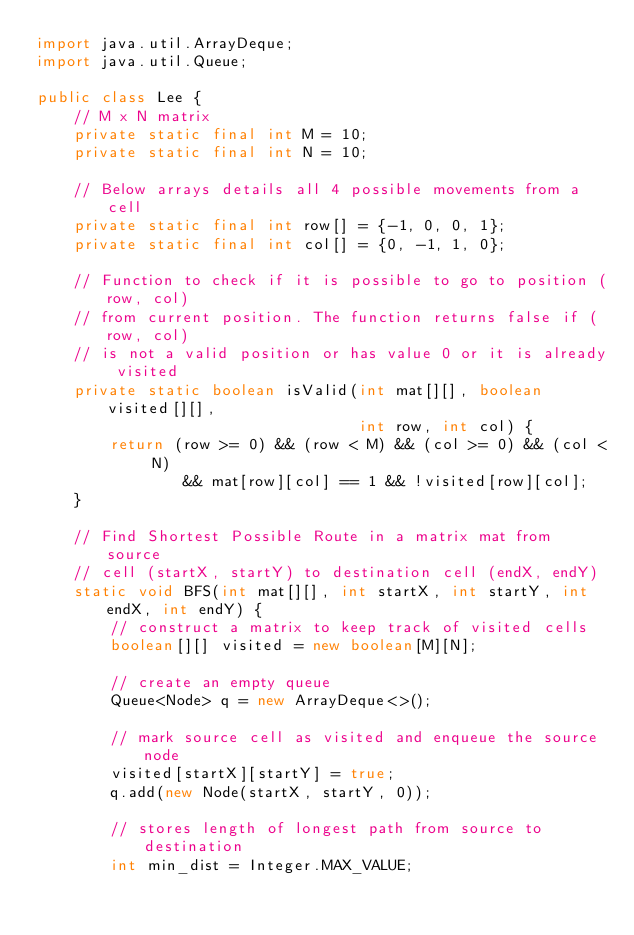Convert code to text. <code><loc_0><loc_0><loc_500><loc_500><_Java_>import java.util.ArrayDeque;
import java.util.Queue;

public class Lee {
    // M x N matrix
    private static final int M = 10;
    private static final int N = 10;

    // Below arrays details all 4 possible movements from a cell
    private static final int row[] = {-1, 0, 0, 1};
    private static final int col[] = {0, -1, 1, 0};

    // Function to check if it is possible to go to position (row, col)
    // from current position. The function returns false if (row, col)
    // is not a valid position or has value 0 or it is already visited
    private static boolean isValid(int mat[][], boolean visited[][],
                                   int row, int col) {
        return (row >= 0) && (row < M) && (col >= 0) && (col < N)
                && mat[row][col] == 1 && !visited[row][col];
    }

    // Find Shortest Possible Route in a matrix mat from source
    // cell (startX, startY) to destination cell (endX, endY)
    static void BFS(int mat[][], int startX, int startY, int endX, int endY) {
        // construct a matrix to keep track of visited cells
        boolean[][] visited = new boolean[M][N];

        // create an empty queue
        Queue<Node> q = new ArrayDeque<>();

        // mark source cell as visited and enqueue the source node
        visited[startX][startY] = true;
        q.add(new Node(startX, startY, 0));

        // stores length of longest path from source to destination
        int min_dist = Integer.MAX_VALUE;
</code> 